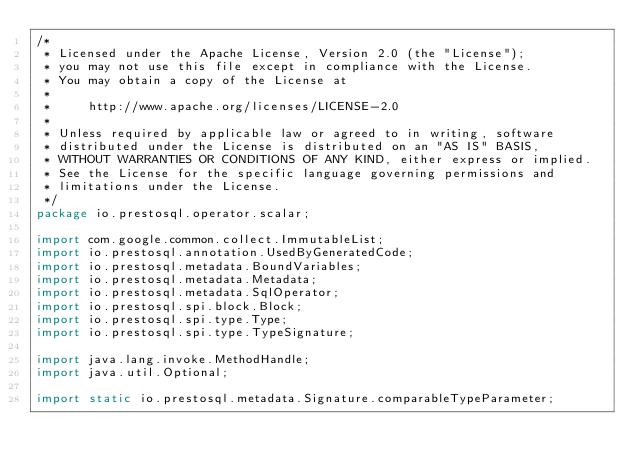Convert code to text. <code><loc_0><loc_0><loc_500><loc_500><_Java_>/*
 * Licensed under the Apache License, Version 2.0 (the "License");
 * you may not use this file except in compliance with the License.
 * You may obtain a copy of the License at
 *
 *     http://www.apache.org/licenses/LICENSE-2.0
 *
 * Unless required by applicable law or agreed to in writing, software
 * distributed under the License is distributed on an "AS IS" BASIS,
 * WITHOUT WARRANTIES OR CONDITIONS OF ANY KIND, either express or implied.
 * See the License for the specific language governing permissions and
 * limitations under the License.
 */
package io.prestosql.operator.scalar;

import com.google.common.collect.ImmutableList;
import io.prestosql.annotation.UsedByGeneratedCode;
import io.prestosql.metadata.BoundVariables;
import io.prestosql.metadata.Metadata;
import io.prestosql.metadata.SqlOperator;
import io.prestosql.spi.block.Block;
import io.prestosql.spi.type.Type;
import io.prestosql.spi.type.TypeSignature;

import java.lang.invoke.MethodHandle;
import java.util.Optional;

import static io.prestosql.metadata.Signature.comparableTypeParameter;</code> 